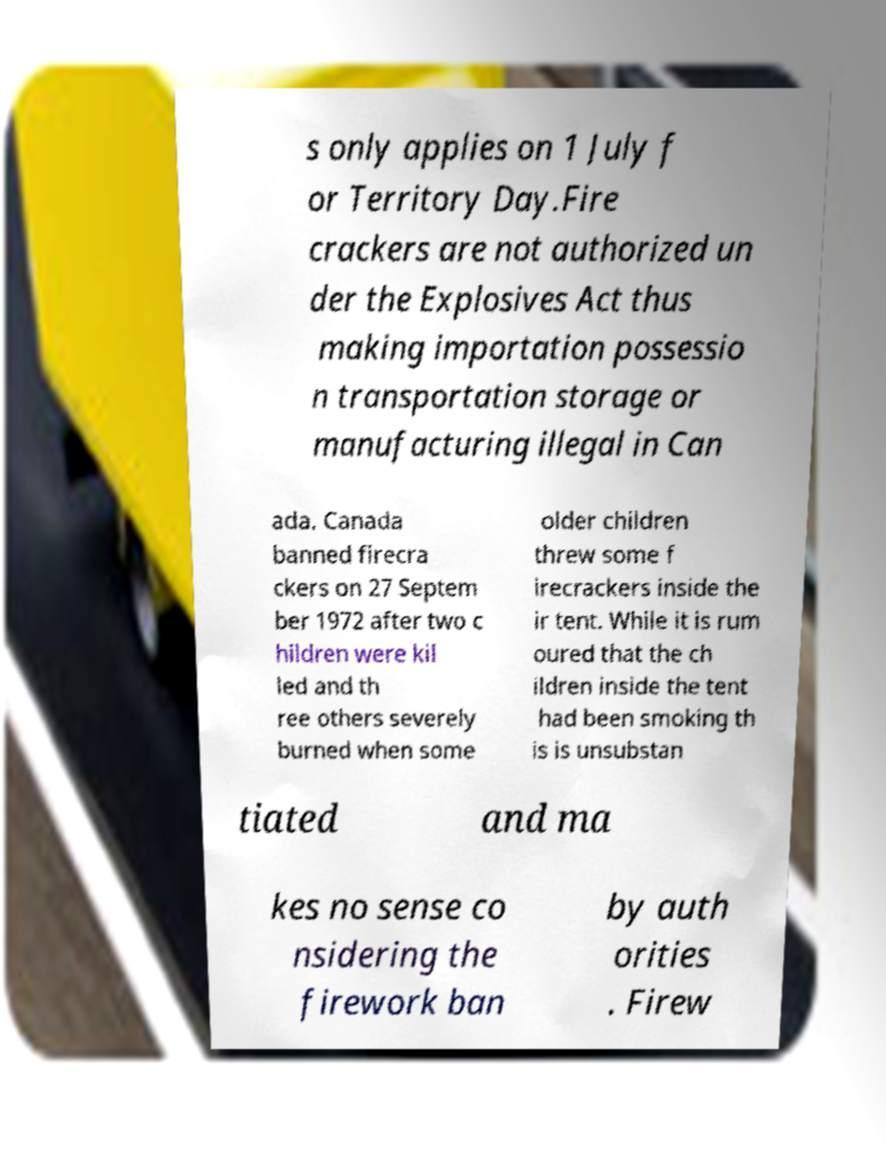I need the written content from this picture converted into text. Can you do that? s only applies on 1 July f or Territory Day.Fire crackers are not authorized un der the Explosives Act thus making importation possessio n transportation storage or manufacturing illegal in Can ada. Canada banned firecra ckers on 27 Septem ber 1972 after two c hildren were kil led and th ree others severely burned when some older children threw some f irecrackers inside the ir tent. While it is rum oured that the ch ildren inside the tent had been smoking th is is unsubstan tiated and ma kes no sense co nsidering the firework ban by auth orities . Firew 